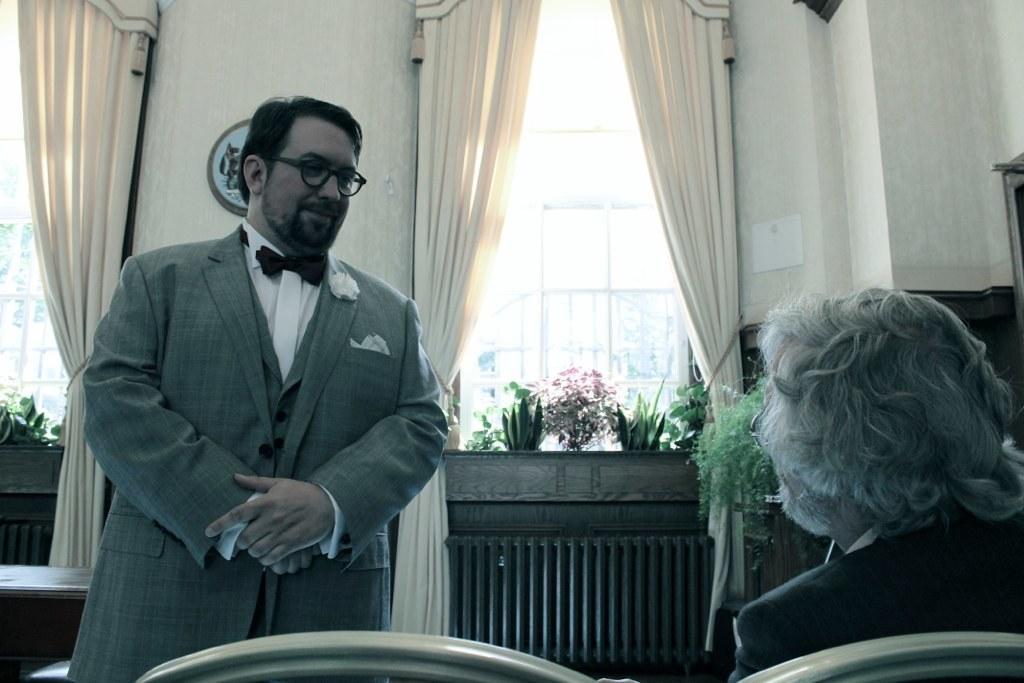Describe this image in one or two sentences. In the image there is a man in grey suit standing on the left side, on the right side there is an old man sitting on chairs, in the back there is window with curtains and plants in front of it. 